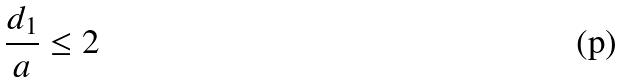<formula> <loc_0><loc_0><loc_500><loc_500>\frac { d _ { 1 } } { a } \leq 2</formula> 